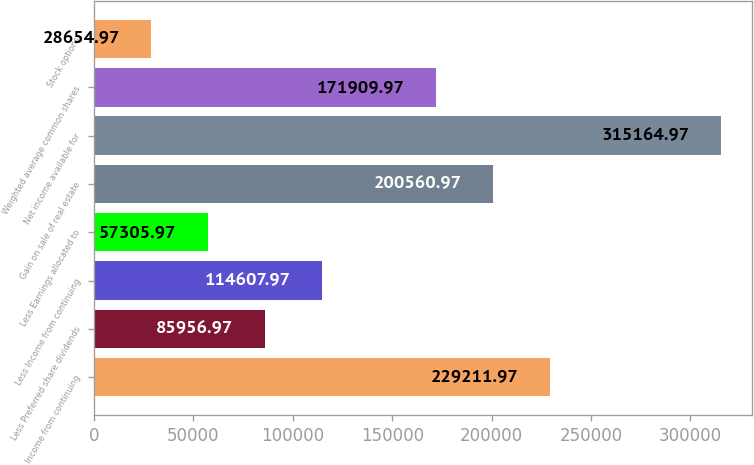Convert chart. <chart><loc_0><loc_0><loc_500><loc_500><bar_chart><fcel>Income from continuing<fcel>Less Preferred share dividends<fcel>Less Income from continuing<fcel>Less Earnings allocated to<fcel>Gain on sale of real estate<fcel>Net income available for<fcel>Weighted average common shares<fcel>Stock options<nl><fcel>229212<fcel>85957<fcel>114608<fcel>57306<fcel>200561<fcel>315165<fcel>171910<fcel>28655<nl></chart> 